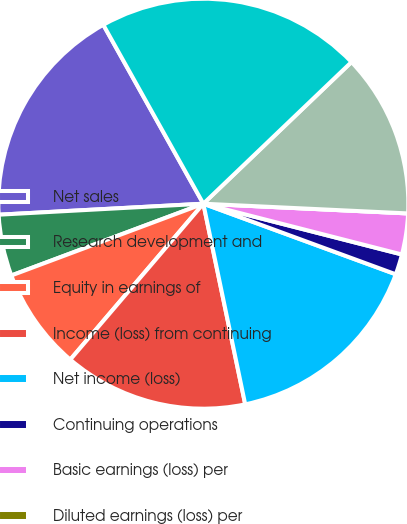<chart> <loc_0><loc_0><loc_500><loc_500><pie_chart><fcel>Net sales<fcel>Research development and<fcel>Equity in earnings of<fcel>Income (loss) from continuing<fcel>Net income (loss)<fcel>Continuing operations<fcel>Basic earnings (loss) per<fcel>Diluted earnings (loss) per<fcel>Working capital<fcel>Total assets<nl><fcel>17.74%<fcel>4.84%<fcel>8.06%<fcel>14.52%<fcel>16.13%<fcel>1.61%<fcel>3.23%<fcel>0.0%<fcel>12.9%<fcel>20.97%<nl></chart> 